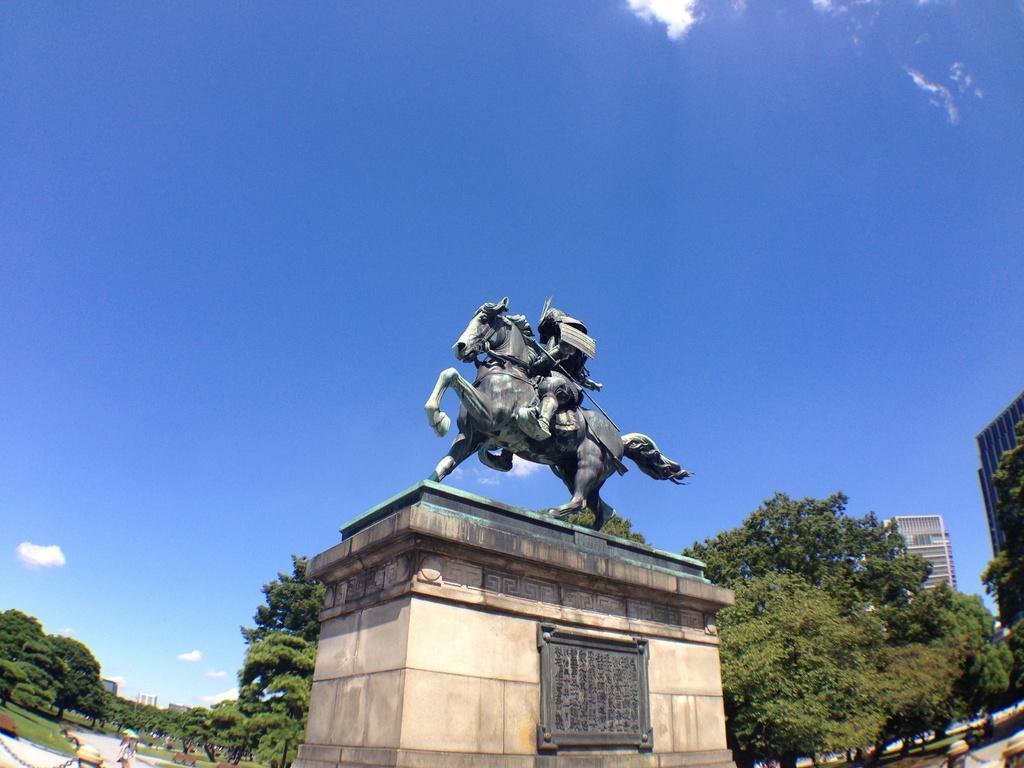How would you summarize this image in a sentence or two? In this picture we can see a statue in the middle of the image, in the background we can see few trees and buildings, and also we can see a person at the bottom of the image. 